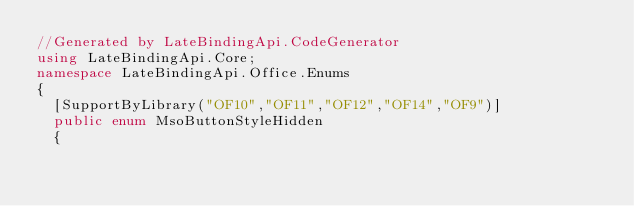Convert code to text. <code><loc_0><loc_0><loc_500><loc_500><_C#_>//Generated by LateBindingApi.CodeGenerator
using LateBindingApi.Core;
namespace LateBindingApi.Office.Enums
{
	[SupportByLibrary("OF10","OF11","OF12","OF14","OF9")]
	public enum MsoButtonStyleHidden
	{</code> 